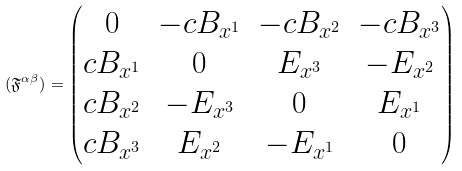Convert formula to latex. <formula><loc_0><loc_0><loc_500><loc_500>( \mathfrak { F } ^ { \alpha \beta } ) = \begin{pmatrix} 0 & - c B _ { x ^ { 1 } } & - c B _ { x ^ { 2 } } & - c B _ { x ^ { 3 } } \\ c B _ { x ^ { 1 } } & 0 & E _ { x ^ { 3 } } & - E _ { x ^ { 2 } } \\ c B _ { x ^ { 2 } } & - E _ { x ^ { 3 } } & 0 & E _ { x ^ { 1 } } \\ c B _ { x ^ { 3 } } & E _ { x ^ { 2 } } & - E _ { x ^ { 1 } } & 0 \end{pmatrix}</formula> 